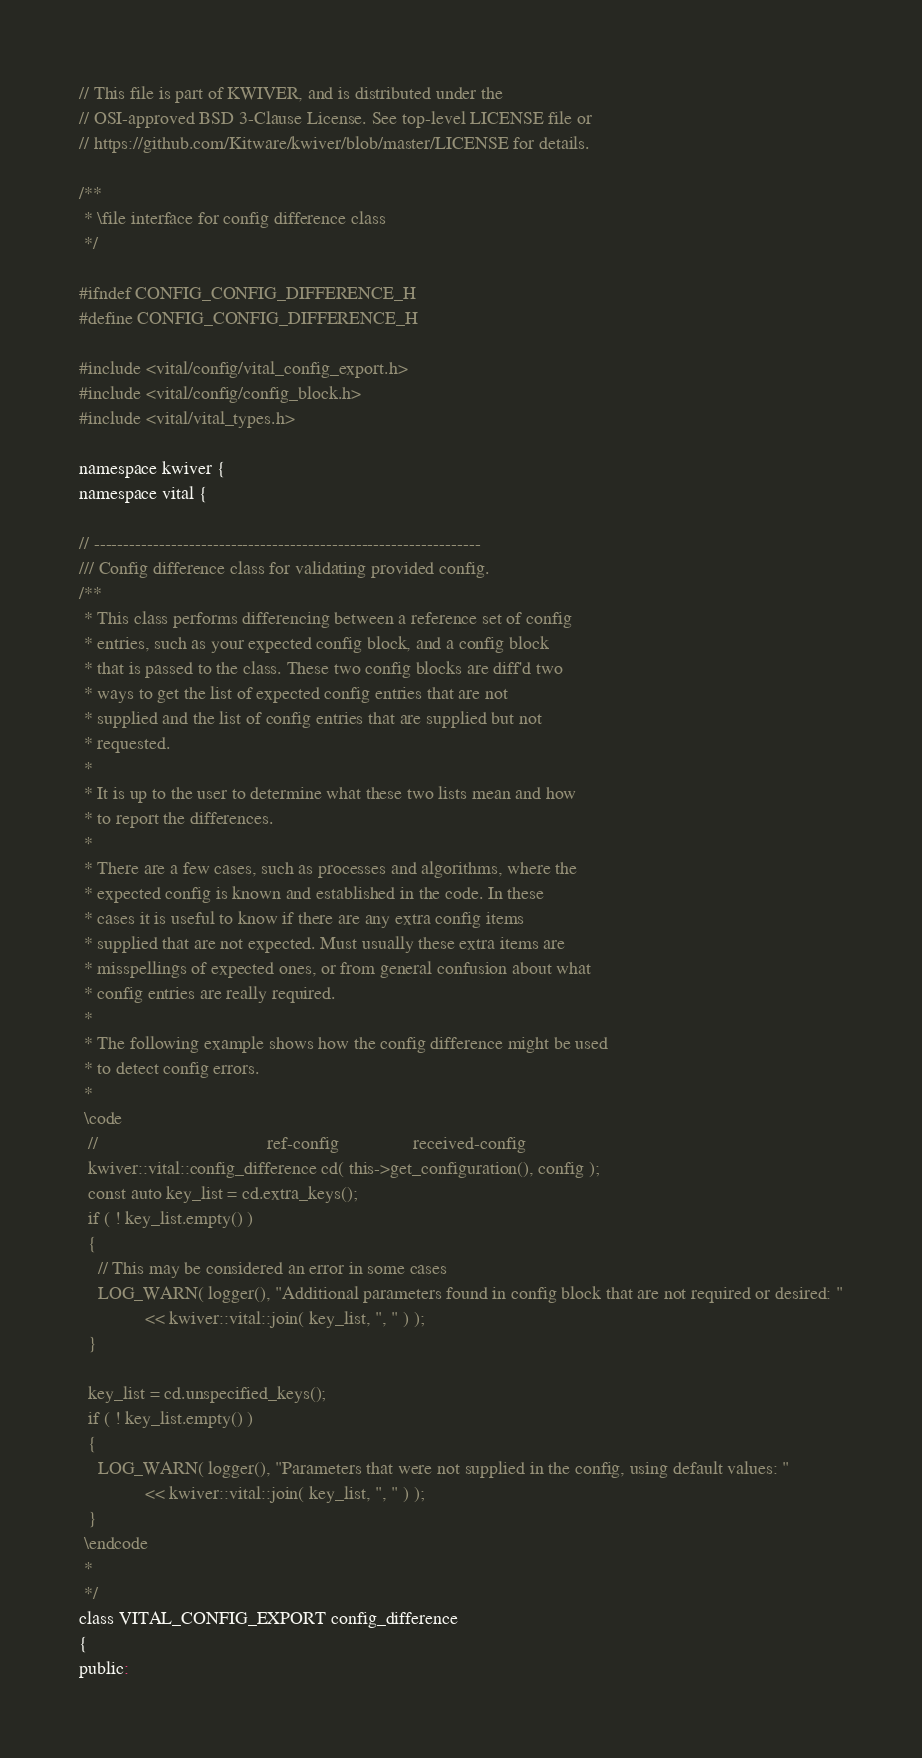Convert code to text. <code><loc_0><loc_0><loc_500><loc_500><_C_>// This file is part of KWIVER, and is distributed under the
// OSI-approved BSD 3-Clause License. See top-level LICENSE file or
// https://github.com/Kitware/kwiver/blob/master/LICENSE for details.

/**
 * \file interface for config difference class
 */

#ifndef CONFIG_CONFIG_DIFFERENCE_H
#define CONFIG_CONFIG_DIFFERENCE_H

#include <vital/config/vital_config_export.h>
#include <vital/config/config_block.h>
#include <vital/vital_types.h>

namespace kwiver {
namespace vital {

// -----------------------------------------------------------------
/// Config difference class for validating provided config.
/**
 * This class performs differencing between a reference set of config
 * entries, such as your expected config block, and a config block
 * that is passed to the class. These two config blocks are diff'd two
 * ways to get the list of expected config entries that are not
 * supplied and the list of config entries that are supplied but not
 * requested.
 *
 * It is up to the user to determine what these two lists mean and how
 * to report the differences.
 *
 * There are a few cases, such as processes and algorithms, where the
 * expected config is known and established in the code. In these
 * cases it is useful to know if there are any extra config items
 * supplied that are not expected. Must usually these extra items are
 * misspellings of expected ones, or from general confusion about what
 * config entries are really required.
 *
 * The following example shows how the config difference might be used
 * to detect config errors.
 *
 \code
  //                                    ref-config                received-config
  kwiver::vital::config_difference cd( this->get_configuration(), config );
  const auto key_list = cd.extra_keys();
  if ( ! key_list.empty() )
  {
    // This may be considered an error in some cases
    LOG_WARN( logger(), "Additional parameters found in config block that are not required or desired: "
              << kwiver::vital::join( key_list, ", " ) );
  }

  key_list = cd.unspecified_keys();
  if ( ! key_list.empty() )
  {
    LOG_WARN( logger(), "Parameters that were not supplied in the config, using default values: "
              << kwiver::vital::join( key_list, ", " ) );
  }
 \endcode
 *
 */
class VITAL_CONFIG_EXPORT config_difference
{
public:</code> 